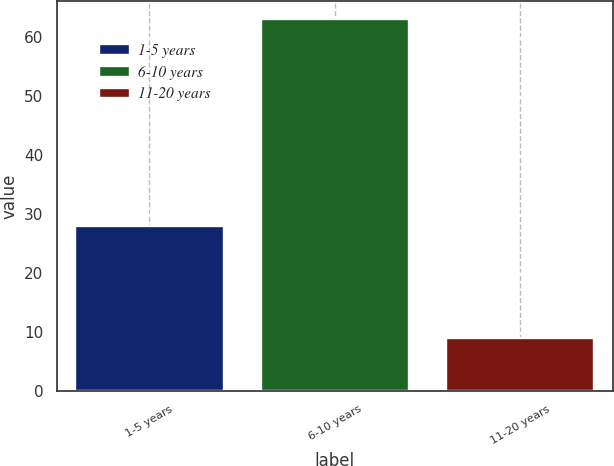Convert chart. <chart><loc_0><loc_0><loc_500><loc_500><bar_chart><fcel>1-5 years<fcel>6-10 years<fcel>11-20 years<nl><fcel>28<fcel>63<fcel>9<nl></chart> 